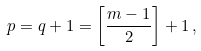Convert formula to latex. <formula><loc_0><loc_0><loc_500><loc_500>p = q + 1 = \left [ \frac { m - 1 } { 2 } \right ] + 1 \, ,</formula> 